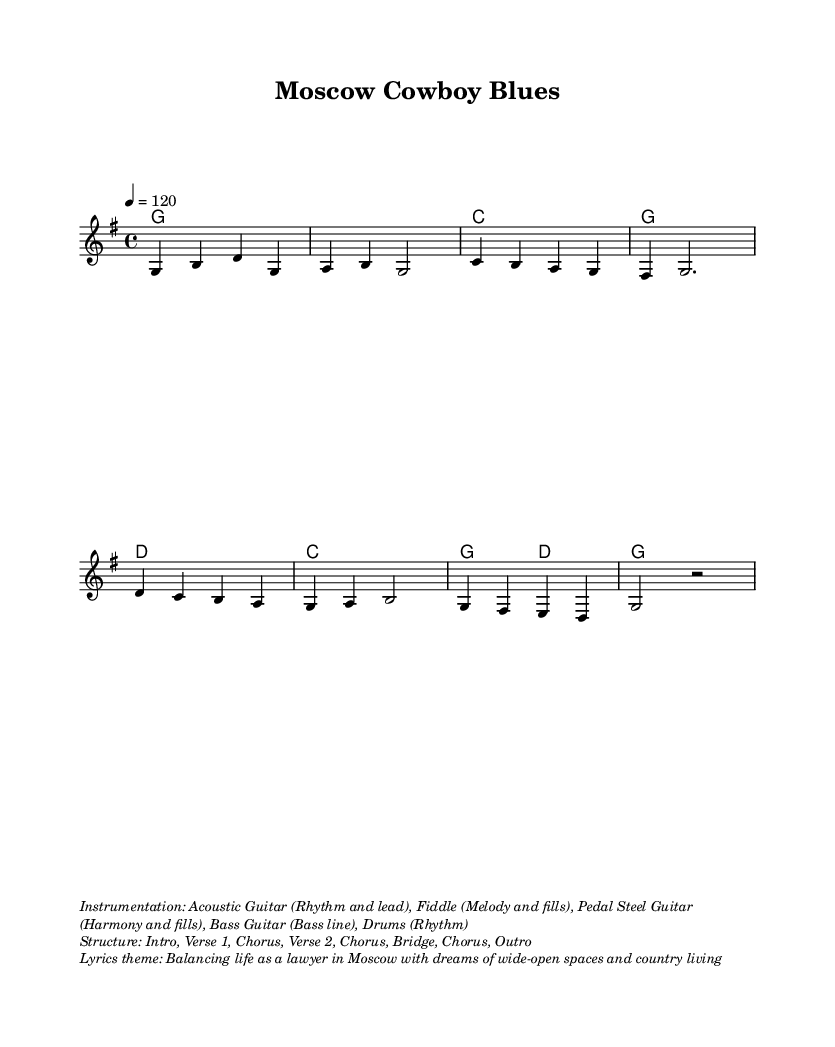What is the key signature of this music? The key signature is G major, which contains one sharp (F#). This can be identified at the beginning of the sheet music where the key signature is indicated.
Answer: G major What is the time signature of this music? The time signature is 4/4, meaning there are four beats in each measure and a quarter note receives one beat. This is noted at the beginning of the score next to the key signature.
Answer: 4/4 What is the tempo marking of this music? The tempo marking is 120 beats per minute, indicated by "4 = 120" at the beginning of the sheet. This directs the performer to play at this speed.
Answer: 120 How many verses are in the structure of this music? The structure includes two verses (Verse 1 and Verse 2) before the final chorus, as described in the markup section detailing the song structure.
Answer: 2 What instruments are used in this piece? The instrumentation includes Acoustic Guitar, Fiddle, Pedal Steel Guitar, Bass Guitar, and Drums, which are all listed in the markup about instrumentation.
Answer: Acoustic Guitar, Fiddle, Pedal Steel Guitar, Bass Guitar, Drums What is the primary lyrical theme of this song? The lyrics theme focuses on balancing life as a lawyer in Moscow with dreams of wide-open spaces and country living, as stated in the lyrics theme markup.
Answer: Balancing life What is the second chord in the harmony progression? The second chord in the harmony progression is C major, which can be identified in the chord changes listed in the score.
Answer: C 